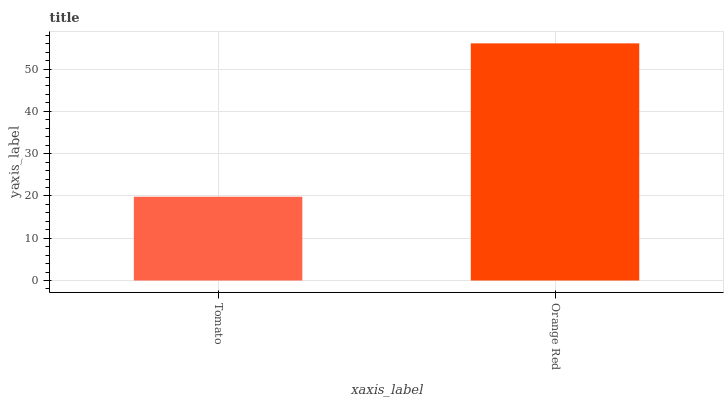Is Tomato the minimum?
Answer yes or no. Yes. Is Orange Red the maximum?
Answer yes or no. Yes. Is Orange Red the minimum?
Answer yes or no. No. Is Orange Red greater than Tomato?
Answer yes or no. Yes. Is Tomato less than Orange Red?
Answer yes or no. Yes. Is Tomato greater than Orange Red?
Answer yes or no. No. Is Orange Red less than Tomato?
Answer yes or no. No. Is Orange Red the high median?
Answer yes or no. Yes. Is Tomato the low median?
Answer yes or no. Yes. Is Tomato the high median?
Answer yes or no. No. Is Orange Red the low median?
Answer yes or no. No. 